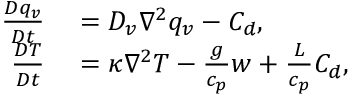Convert formula to latex. <formula><loc_0><loc_0><loc_500><loc_500>\begin{array} { r l } { \frac { D q _ { v } } { D t } } & = D _ { v } \nabla ^ { 2 } q _ { v } - C _ { d } , } \\ { \frac { D T } { D t } } & = \kappa \nabla ^ { 2 } T - \frac { g } { c _ { p } } w + \frac { L } { c _ { p } } C _ { d } , } \end{array}</formula> 